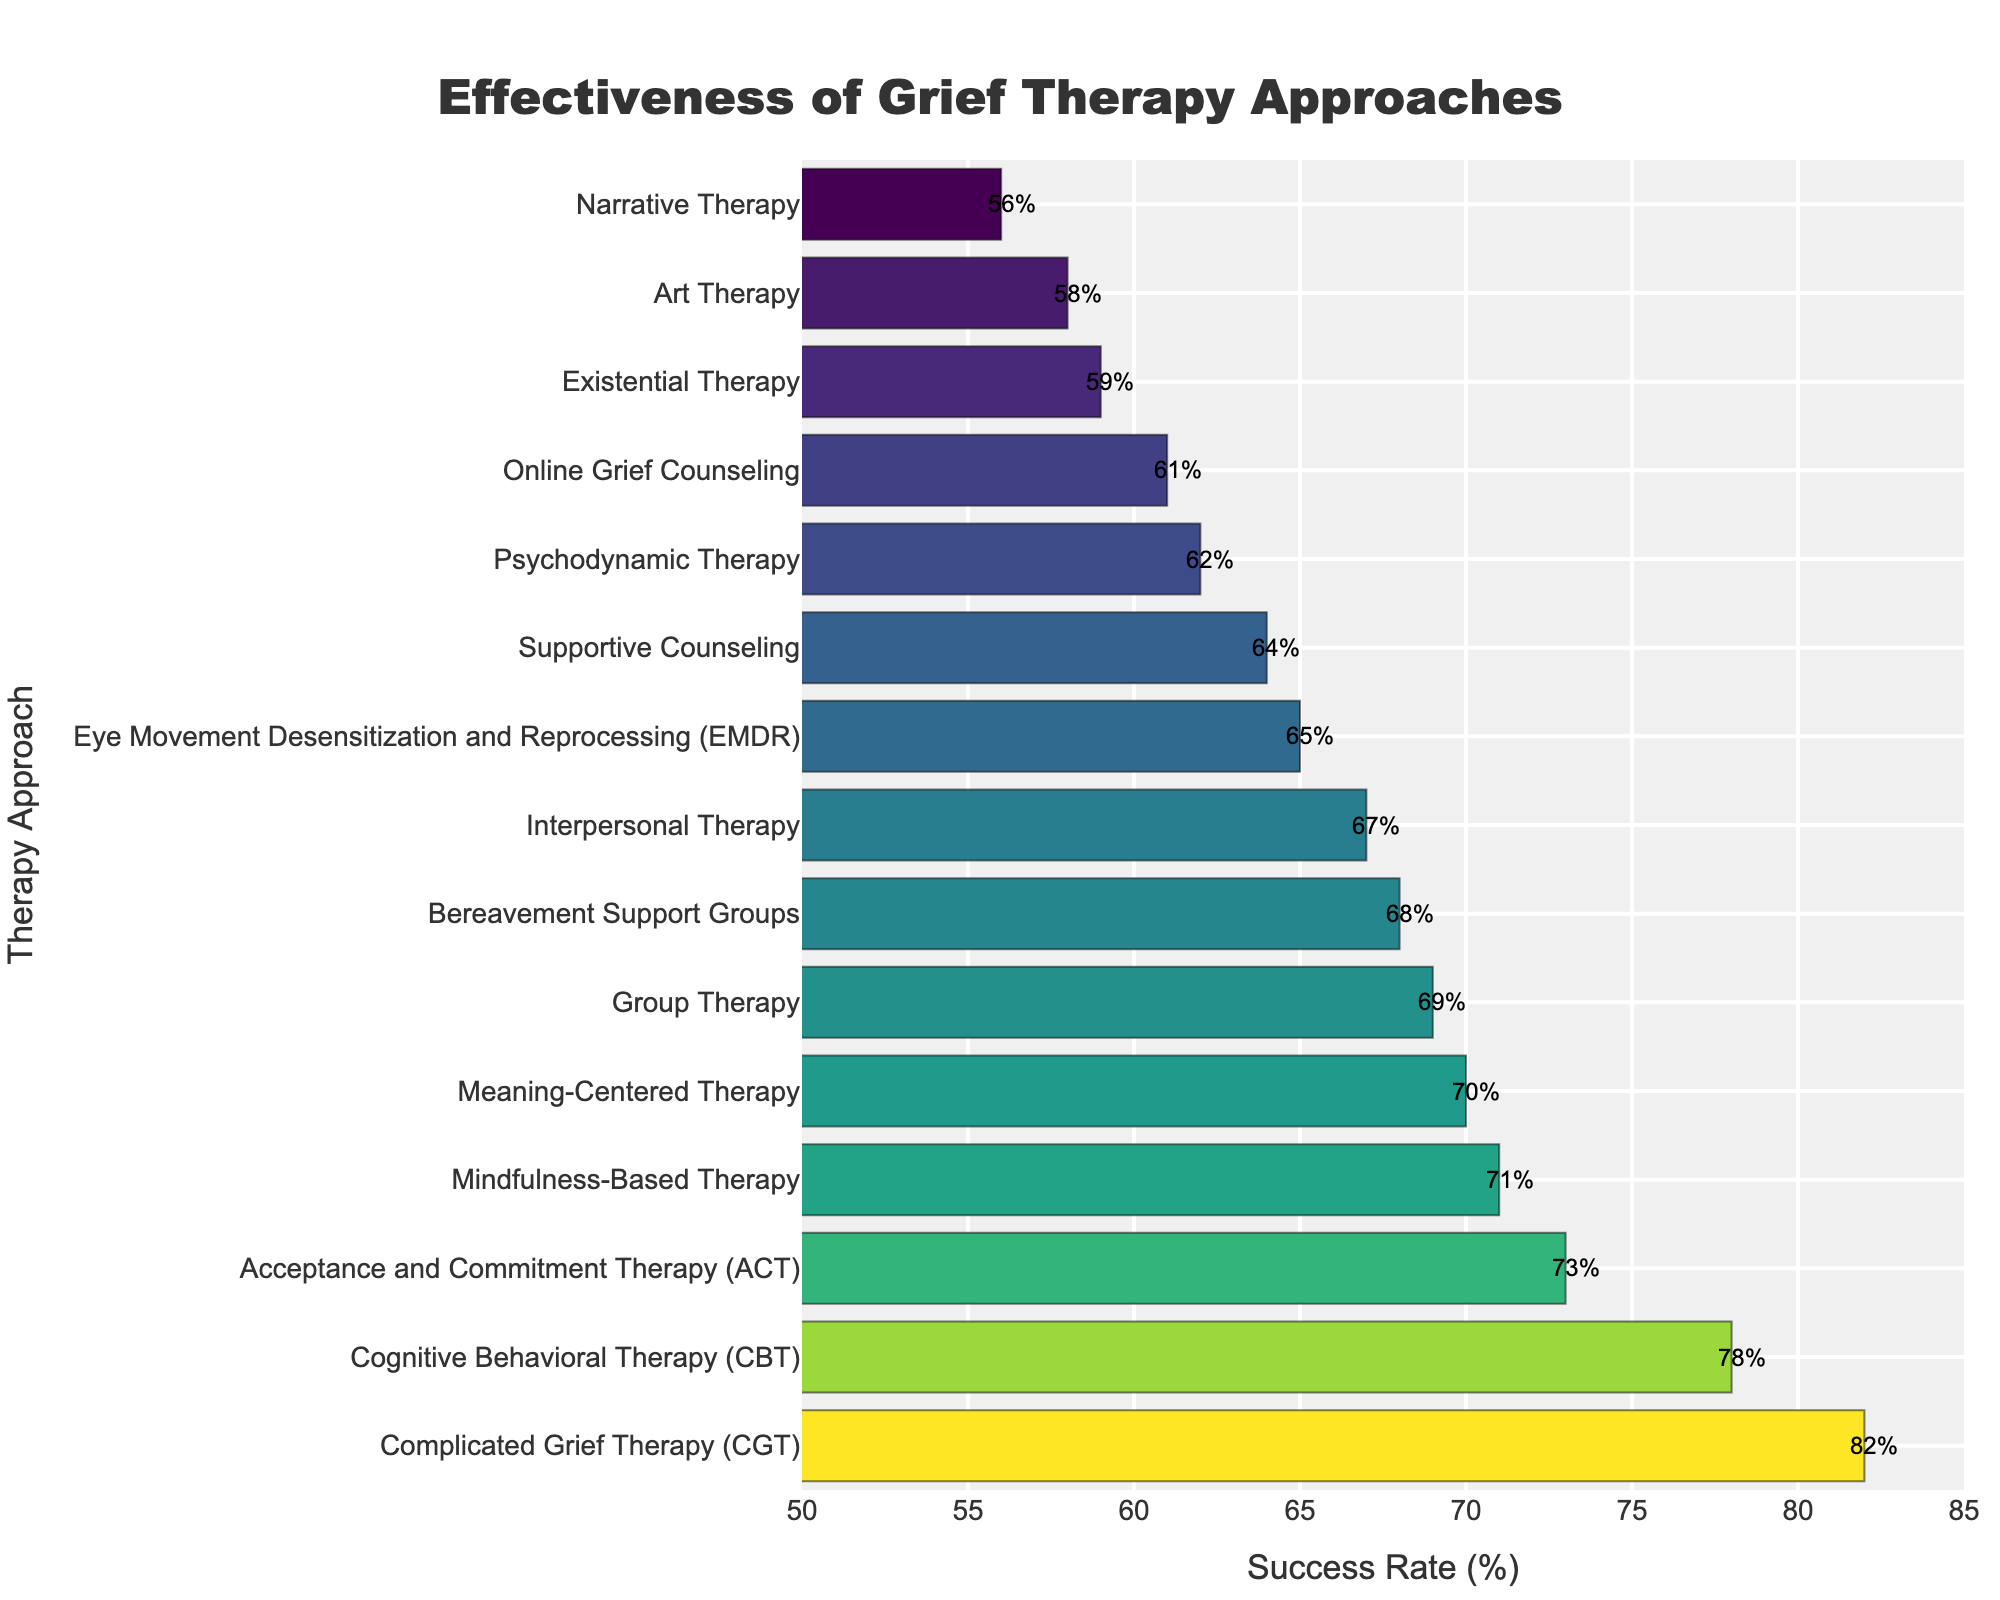What is the success rate for Cognitive Behavioral Therapy (CBT)? To find the success rate for Cognitive Behavioral Therapy (CBT), look at the bar labeled "Cognitive Behavioral Therapy (CBT)" and find the value at the end of the bar.
Answer: 78% Which therapy approach has the highest success rate? To determine which therapy approach has the highest success rate, look for the bar that extends the farthest to the right.
Answer: Complicated Grief Therapy (CGT) How much greater is the success rate of Acceptance and Commitment Therapy (ACT) compared to Eye Movement Desensitization and Reprocessing (EMDR)? Find the success rates of ACT and EMDR from their respective bars: ACT is 73% and EMDR is 65%. The difference is calculated as 73% - 65%.
Answer: 8% Which therapy has a higher success rate: Group Therapy or Online Grief Counseling? Compare the lengths of the bars for Group Therapy and Online Grief Counseling. Group Therapy has a success rate of 69%, while Online Grief Counseling has a success rate of 61%.
Answer: Group Therapy What is the average success rate of the top three therapies in the chart? Identify the success rates of the top three therapies: CGT (82%), CBT (78%), and ACT (73%). Sum these and divide by the number of therapies: (82% + 78% + 73%) / 3.
Answer: 77.67% How many therapies have a success rate of 70% or above? Count the bars that extend to at least the 70% mark: CGT (82%), CBT (78%), ACT (73%), and Mindfulness-Based Therapy (71%).
Answer: 4 Which therapy has a lower success rate: Interpersonal Therapy or Meaning-Centered Therapy? Compare the bars of Interpersonal Therapy (67%) and Meaning-Centered Therapy (70%).
Answer: Interpersonal Therapy What is the range of success rates shown in the chart? Identify the highest success rate (CGT at 82%) and the lowest success rate (Narrative Therapy at 56%). The range is the difference between the highest and lowest values: 82% - 56%.
Answer: 26% Which therapy approach is just above Supportive Counseling in terms of success rate? Identify the success rate of Supportive Counseling (64%) and find the bar immediately above it (Psychodynamic Therapy with 62%).
Answer: Psychodynamic Therapy Do more therapies have a success rate above or below 65%? Count the therapies with a success rate above 65% (8) and those with a success rate below 65% (7).
Answer: Above 65% 